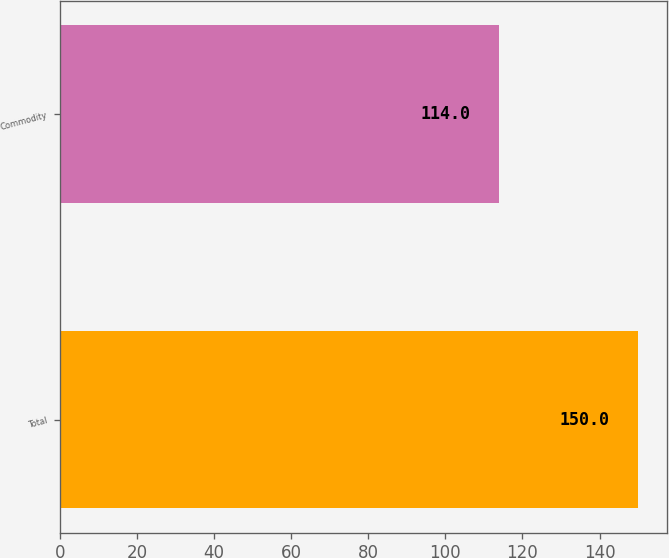Convert chart to OTSL. <chart><loc_0><loc_0><loc_500><loc_500><bar_chart><fcel>Total<fcel>Commodity<nl><fcel>150<fcel>114<nl></chart> 